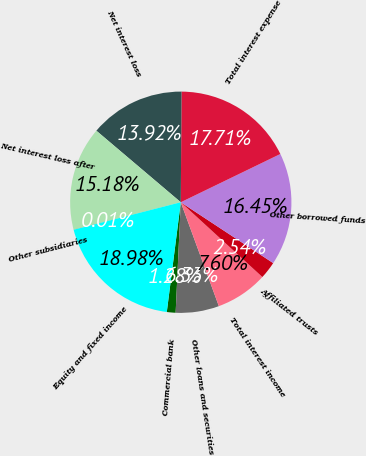<chart> <loc_0><loc_0><loc_500><loc_500><pie_chart><fcel>Commercial bank<fcel>Other loans and securities<fcel>Total interest income<fcel>Affiliated trusts<fcel>Other borrowed funds<fcel>Total interest expense<fcel>Net interest loss<fcel>Net interest loss after<fcel>Other subsidiaries<fcel>Equity and fixed income<nl><fcel>1.28%<fcel>6.33%<fcel>7.6%<fcel>2.54%<fcel>16.45%<fcel>17.71%<fcel>13.92%<fcel>15.18%<fcel>0.01%<fcel>18.98%<nl></chart> 